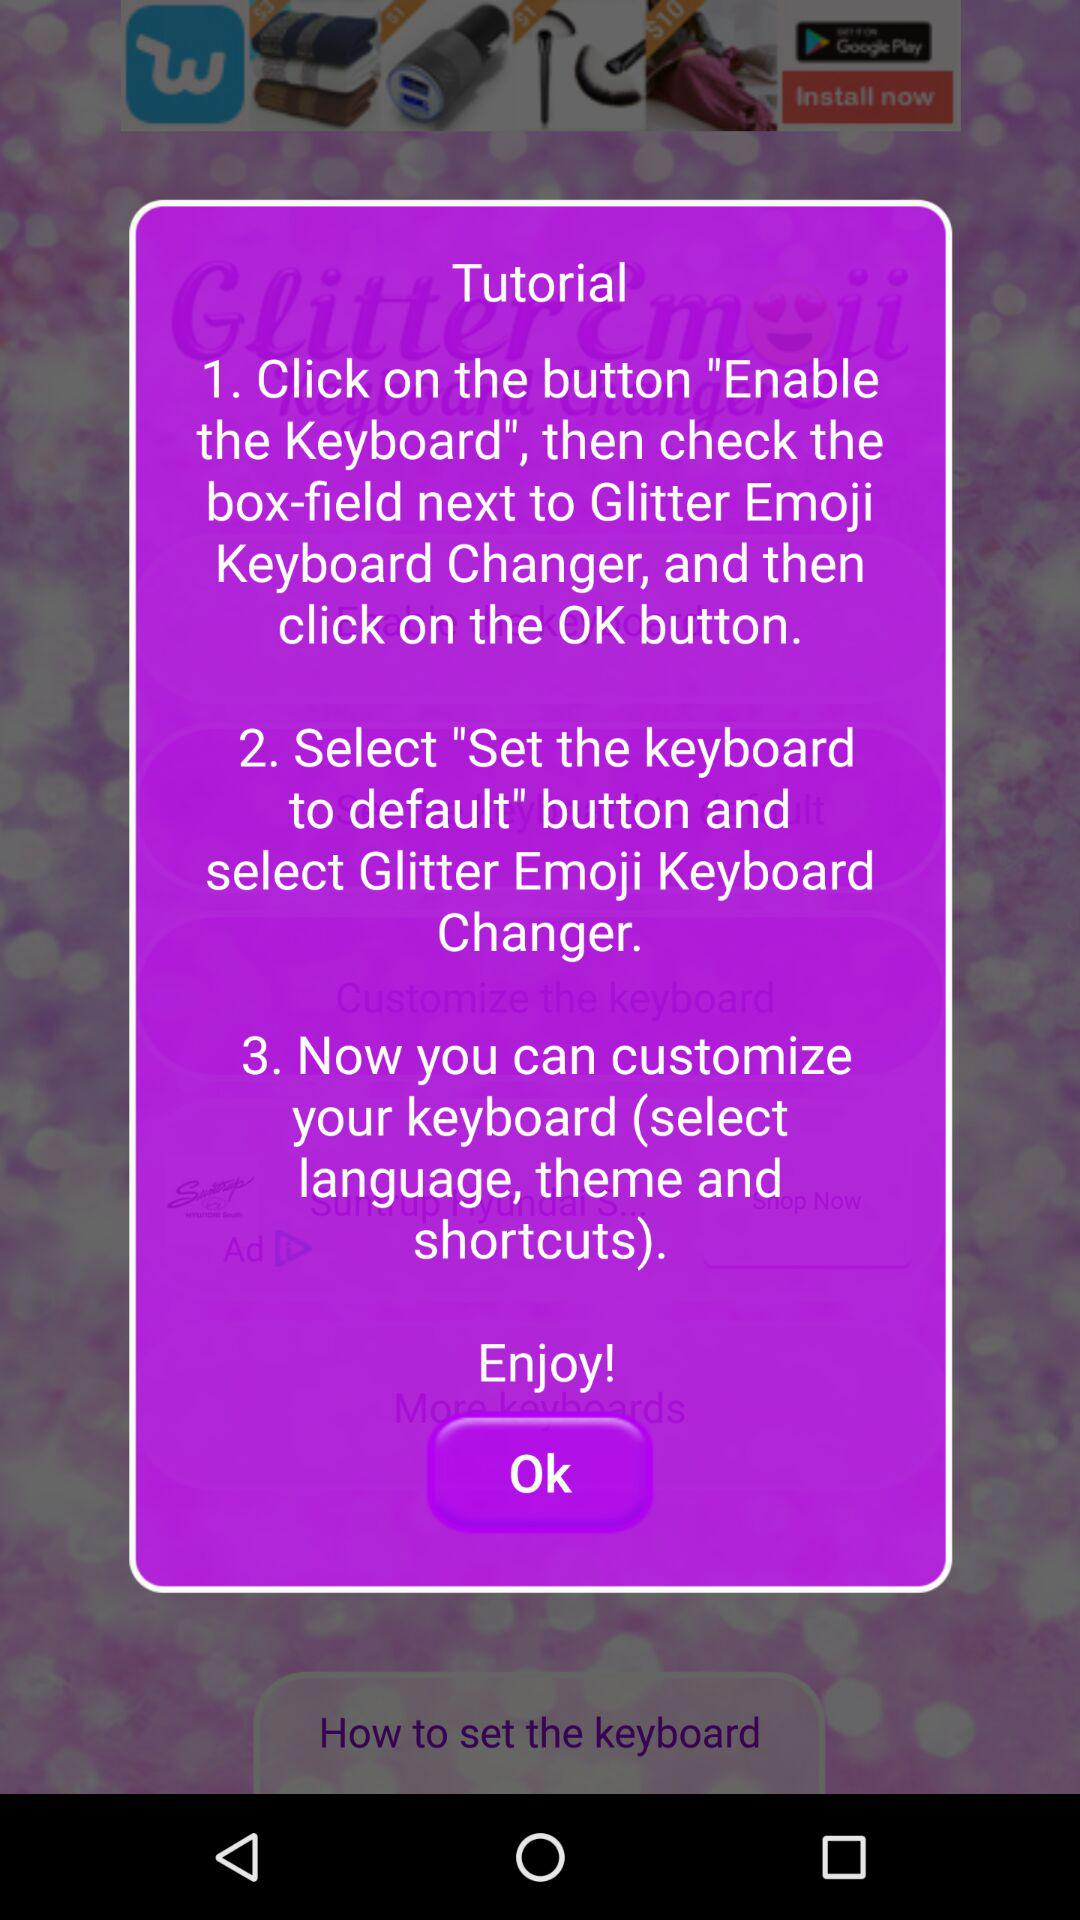How many steps are there in the tutorial?
Answer the question using a single word or phrase. 3 